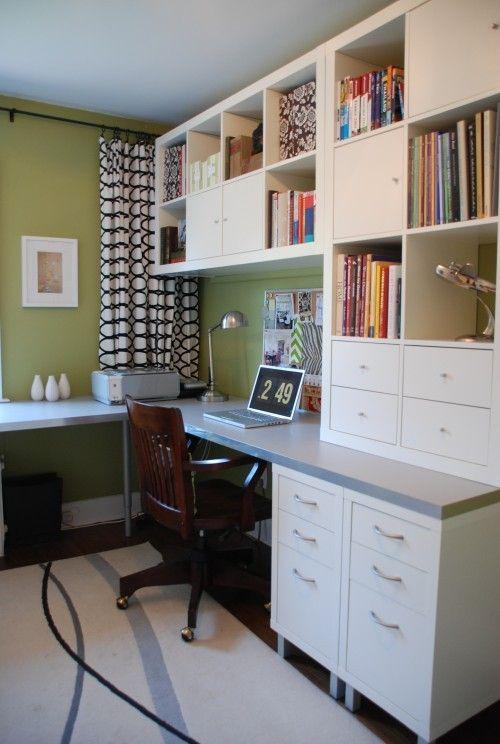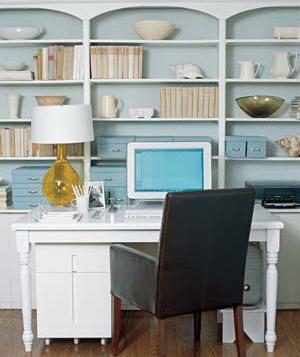The first image is the image on the left, the second image is the image on the right. For the images displayed, is the sentence "In one of the images, the desk chair is white." factually correct? Answer yes or no. No. The first image is the image on the left, the second image is the image on the right. For the images shown, is this caption "Both desks have a computer or monitor visible." true? Answer yes or no. Yes. 